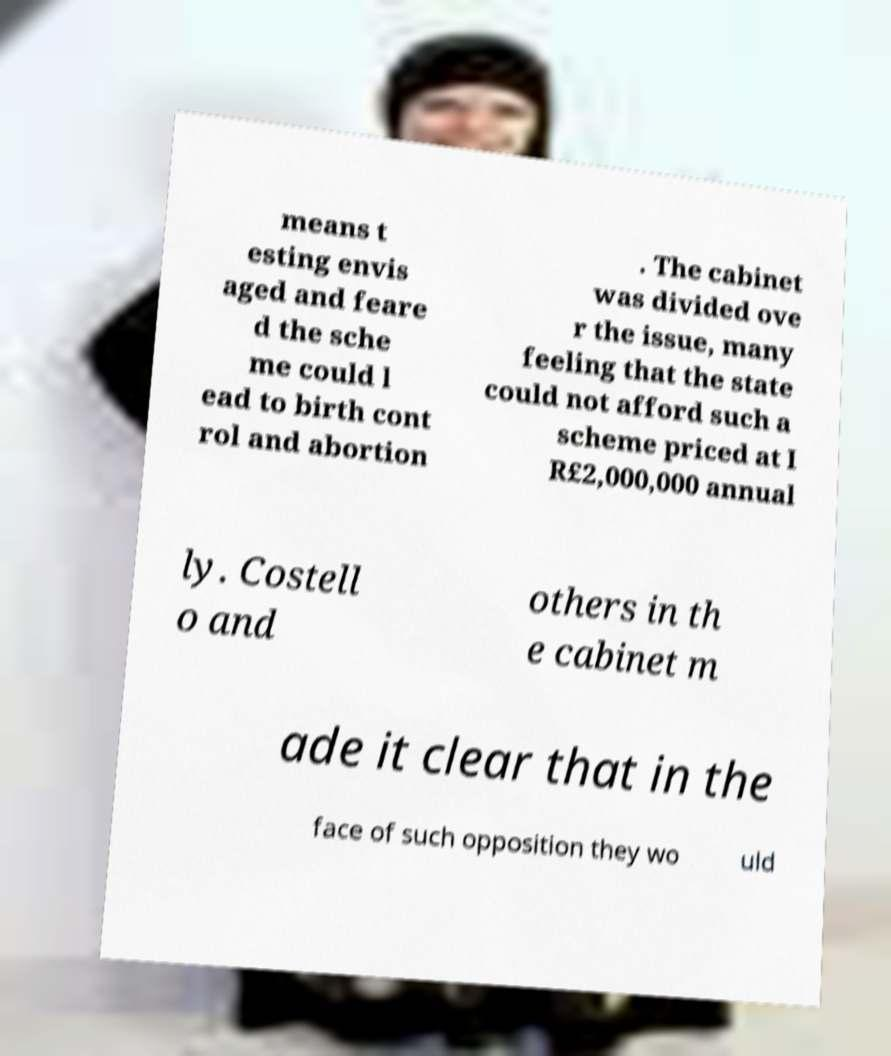What messages or text are displayed in this image? I need them in a readable, typed format. means t esting envis aged and feare d the sche me could l ead to birth cont rol and abortion . The cabinet was divided ove r the issue, many feeling that the state could not afford such a scheme priced at I R£2,000,000 annual ly. Costell o and others in th e cabinet m ade it clear that in the face of such opposition they wo uld 